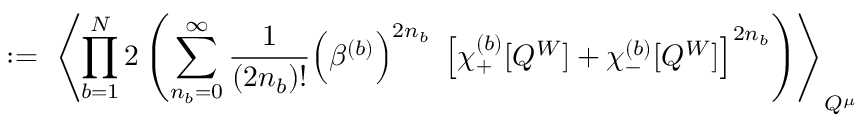Convert formula to latex. <formula><loc_0><loc_0><loc_500><loc_500>\colon = \, \left \langle \prod _ { b = 1 } ^ { N } 2 \left ( \sum _ { n _ { b } = 0 } ^ { \infty } \frac { 1 } { ( 2 n _ { b } ) ! } \left ( \beta ^ { ( b ) } \right ) ^ { 2 n _ { b } } \, \left [ \chi _ { + } ^ { ( b ) } [ Q ^ { W } ] + \chi _ { - } ^ { ( b ) } [ Q ^ { W } ] \right ] ^ { 2 n _ { b } } \right ) \right \rangle _ { Q ^ { \mu } }</formula> 